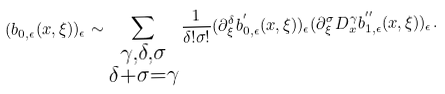<formula> <loc_0><loc_0><loc_500><loc_500>( b _ { 0 , \epsilon } ( x , \xi ) ) _ { \epsilon } \sim \sum _ { \substack { \gamma , \delta , \sigma \\ \delta + \sigma = \gamma } } \frac { 1 } { \delta ! \sigma ! } ( \partial ^ { \delta } _ { \xi } b ^ { ^ { \prime } } _ { 0 , \epsilon } ( x , \xi ) ) _ { \epsilon } ( \partial ^ { \sigma } _ { \xi } D ^ { \gamma } _ { x } b ^ { ^ { \prime \prime } } _ { 1 , \epsilon } ( x , \xi ) ) _ { \epsilon } .</formula> 